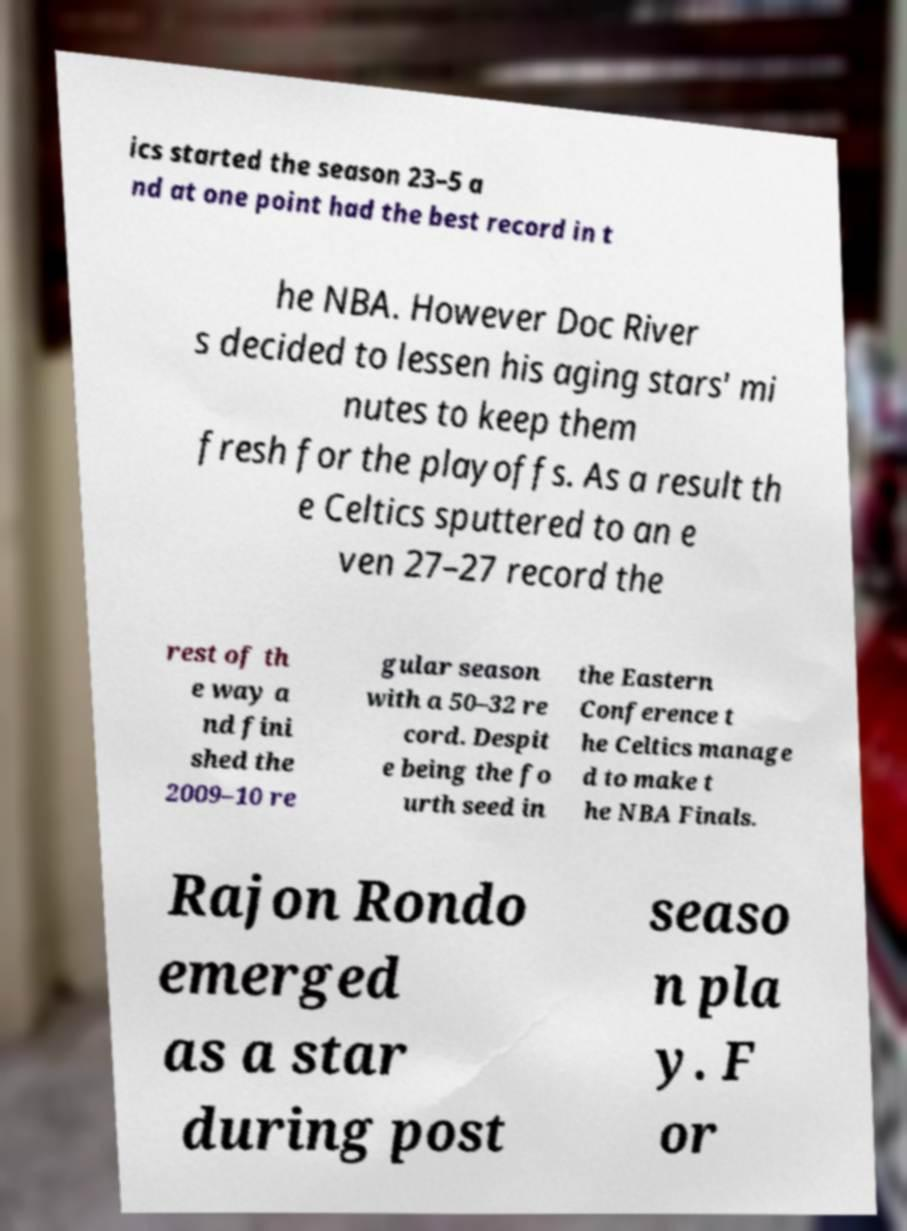Could you assist in decoding the text presented in this image and type it out clearly? ics started the season 23–5 a nd at one point had the best record in t he NBA. However Doc River s decided to lessen his aging stars' mi nutes to keep them fresh for the playoffs. As a result th e Celtics sputtered to an e ven 27–27 record the rest of th e way a nd fini shed the 2009–10 re gular season with a 50–32 re cord. Despit e being the fo urth seed in the Eastern Conference t he Celtics manage d to make t he NBA Finals. Rajon Rondo emerged as a star during post seaso n pla y. F or 